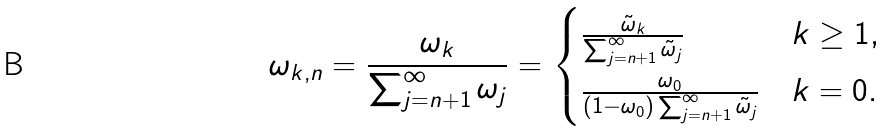Convert formula to latex. <formula><loc_0><loc_0><loc_500><loc_500>\omega _ { k , n } = \frac { \omega _ { k } } { \sum _ { j = n + 1 } ^ { \infty } \omega _ { j } } = \begin{cases} \frac { \tilde { \omega } _ { k } } { \sum _ { j = n + 1 } ^ { \infty } \tilde { \omega } _ { j } } & k \geq 1 , \\ \frac { \omega _ { 0 } } { ( 1 - \omega _ { 0 } ) \sum _ { j = n + 1 } ^ { \infty } \tilde { \omega } _ { j } } & k = 0 . \end{cases}</formula> 